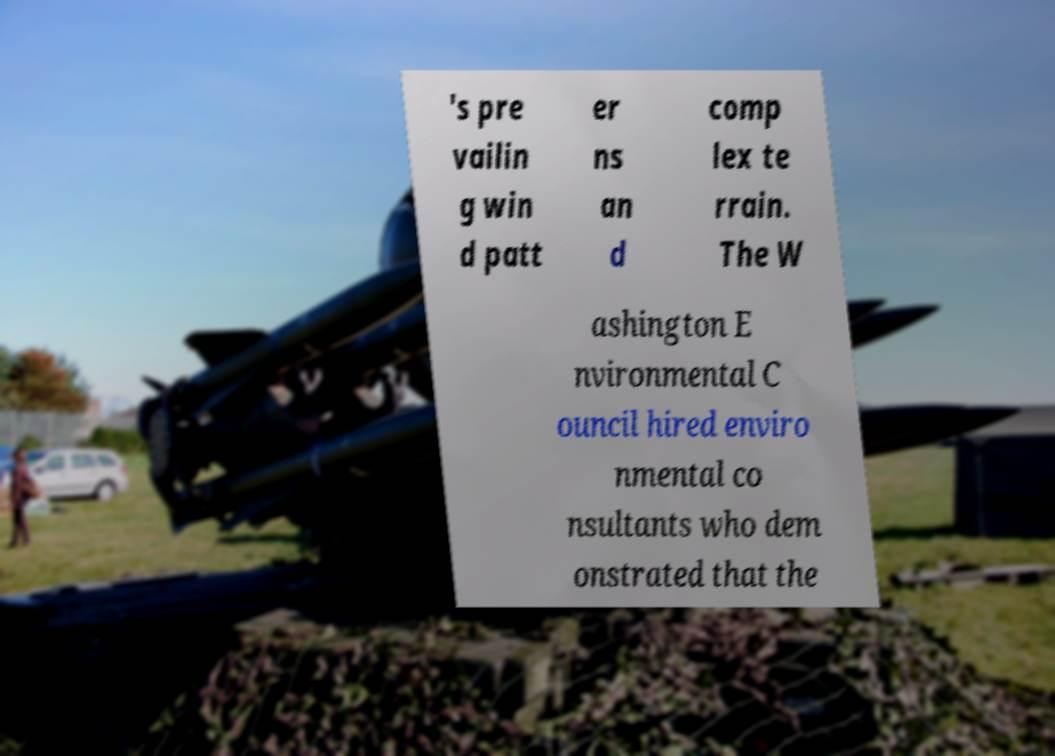Could you extract and type out the text from this image? 's pre vailin g win d patt er ns an d comp lex te rrain. The W ashington E nvironmental C ouncil hired enviro nmental co nsultants who dem onstrated that the 